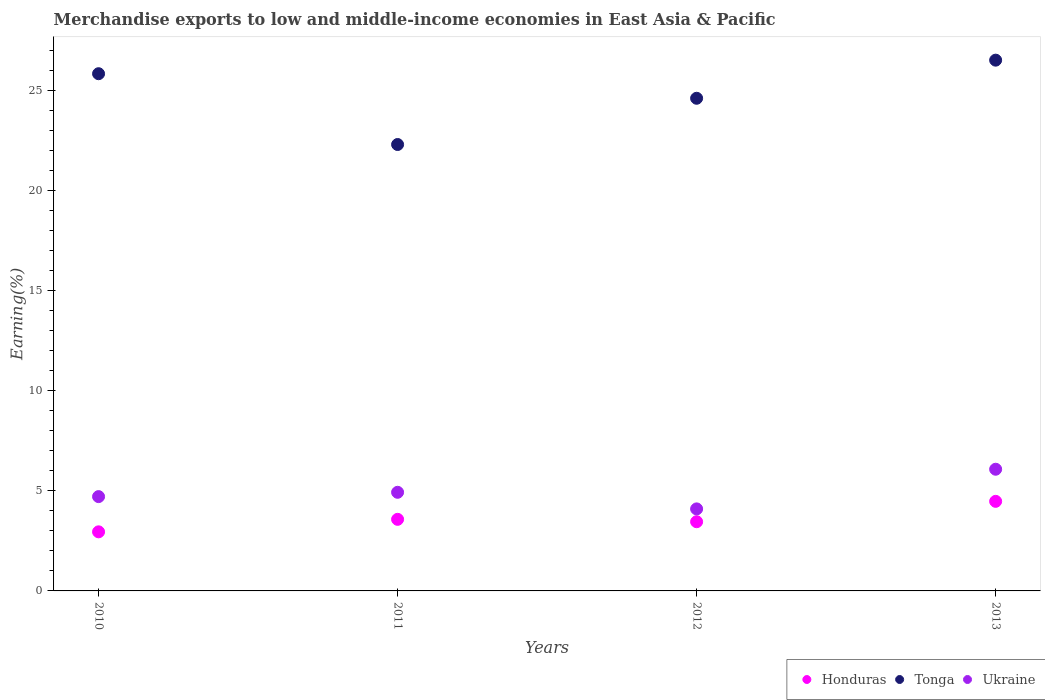What is the percentage of amount earned from merchandise exports in Ukraine in 2012?
Offer a terse response. 4.09. Across all years, what is the maximum percentage of amount earned from merchandise exports in Tonga?
Provide a succinct answer. 26.5. Across all years, what is the minimum percentage of amount earned from merchandise exports in Ukraine?
Make the answer very short. 4.09. In which year was the percentage of amount earned from merchandise exports in Tonga maximum?
Keep it short and to the point. 2013. What is the total percentage of amount earned from merchandise exports in Ukraine in the graph?
Provide a short and direct response. 19.8. What is the difference between the percentage of amount earned from merchandise exports in Ukraine in 2012 and that in 2013?
Your answer should be very brief. -1.98. What is the difference between the percentage of amount earned from merchandise exports in Ukraine in 2013 and the percentage of amount earned from merchandise exports in Honduras in 2010?
Provide a short and direct response. 3.12. What is the average percentage of amount earned from merchandise exports in Ukraine per year?
Keep it short and to the point. 4.95. In the year 2011, what is the difference between the percentage of amount earned from merchandise exports in Tonga and percentage of amount earned from merchandise exports in Honduras?
Your response must be concise. 18.71. What is the ratio of the percentage of amount earned from merchandise exports in Ukraine in 2012 to that in 2013?
Provide a short and direct response. 0.67. Is the percentage of amount earned from merchandise exports in Honduras in 2011 less than that in 2012?
Provide a short and direct response. No. What is the difference between the highest and the second highest percentage of amount earned from merchandise exports in Tonga?
Offer a terse response. 0.68. What is the difference between the highest and the lowest percentage of amount earned from merchandise exports in Honduras?
Give a very brief answer. 1.52. In how many years, is the percentage of amount earned from merchandise exports in Ukraine greater than the average percentage of amount earned from merchandise exports in Ukraine taken over all years?
Provide a short and direct response. 1. Is the sum of the percentage of amount earned from merchandise exports in Honduras in 2011 and 2012 greater than the maximum percentage of amount earned from merchandise exports in Tonga across all years?
Provide a short and direct response. No. Does the percentage of amount earned from merchandise exports in Tonga monotonically increase over the years?
Keep it short and to the point. No. Is the percentage of amount earned from merchandise exports in Ukraine strictly greater than the percentage of amount earned from merchandise exports in Honduras over the years?
Offer a very short reply. Yes. Is the percentage of amount earned from merchandise exports in Tonga strictly less than the percentage of amount earned from merchandise exports in Ukraine over the years?
Make the answer very short. No. How many dotlines are there?
Provide a succinct answer. 3. How many years are there in the graph?
Keep it short and to the point. 4. Are the values on the major ticks of Y-axis written in scientific E-notation?
Your response must be concise. No. Does the graph contain any zero values?
Provide a short and direct response. No. Does the graph contain grids?
Provide a succinct answer. No. How many legend labels are there?
Your answer should be very brief. 3. How are the legend labels stacked?
Provide a short and direct response. Horizontal. What is the title of the graph?
Your answer should be very brief. Merchandise exports to low and middle-income economies in East Asia & Pacific. What is the label or title of the Y-axis?
Make the answer very short. Earning(%). What is the Earning(%) in Honduras in 2010?
Offer a terse response. 2.95. What is the Earning(%) in Tonga in 2010?
Keep it short and to the point. 25.82. What is the Earning(%) of Ukraine in 2010?
Your answer should be compact. 4.71. What is the Earning(%) of Honduras in 2011?
Give a very brief answer. 3.57. What is the Earning(%) of Tonga in 2011?
Make the answer very short. 22.29. What is the Earning(%) in Ukraine in 2011?
Provide a succinct answer. 4.92. What is the Earning(%) in Honduras in 2012?
Keep it short and to the point. 3.45. What is the Earning(%) of Tonga in 2012?
Your response must be concise. 24.59. What is the Earning(%) in Ukraine in 2012?
Your answer should be very brief. 4.09. What is the Earning(%) in Honduras in 2013?
Your response must be concise. 4.47. What is the Earning(%) of Tonga in 2013?
Ensure brevity in your answer.  26.5. What is the Earning(%) of Ukraine in 2013?
Provide a short and direct response. 6.07. Across all years, what is the maximum Earning(%) in Honduras?
Offer a very short reply. 4.47. Across all years, what is the maximum Earning(%) of Tonga?
Make the answer very short. 26.5. Across all years, what is the maximum Earning(%) in Ukraine?
Your response must be concise. 6.07. Across all years, what is the minimum Earning(%) in Honduras?
Provide a short and direct response. 2.95. Across all years, what is the minimum Earning(%) in Tonga?
Ensure brevity in your answer.  22.29. Across all years, what is the minimum Earning(%) in Ukraine?
Offer a terse response. 4.09. What is the total Earning(%) in Honduras in the graph?
Keep it short and to the point. 14.45. What is the total Earning(%) of Tonga in the graph?
Keep it short and to the point. 99.19. What is the total Earning(%) in Ukraine in the graph?
Your answer should be compact. 19.8. What is the difference between the Earning(%) in Honduras in 2010 and that in 2011?
Your answer should be very brief. -0.62. What is the difference between the Earning(%) of Tonga in 2010 and that in 2011?
Your answer should be very brief. 3.53. What is the difference between the Earning(%) of Ukraine in 2010 and that in 2011?
Make the answer very short. -0.22. What is the difference between the Earning(%) in Honduras in 2010 and that in 2012?
Your answer should be very brief. -0.5. What is the difference between the Earning(%) of Tonga in 2010 and that in 2012?
Give a very brief answer. 1.23. What is the difference between the Earning(%) of Ukraine in 2010 and that in 2012?
Your answer should be compact. 0.61. What is the difference between the Earning(%) of Honduras in 2010 and that in 2013?
Provide a short and direct response. -1.52. What is the difference between the Earning(%) of Tonga in 2010 and that in 2013?
Offer a terse response. -0.68. What is the difference between the Earning(%) in Ukraine in 2010 and that in 2013?
Make the answer very short. -1.37. What is the difference between the Earning(%) of Honduras in 2011 and that in 2012?
Your answer should be compact. 0.12. What is the difference between the Earning(%) of Tonga in 2011 and that in 2012?
Make the answer very short. -2.31. What is the difference between the Earning(%) of Ukraine in 2011 and that in 2012?
Make the answer very short. 0.83. What is the difference between the Earning(%) in Honduras in 2011 and that in 2013?
Make the answer very short. -0.9. What is the difference between the Earning(%) in Tonga in 2011 and that in 2013?
Provide a short and direct response. -4.21. What is the difference between the Earning(%) in Ukraine in 2011 and that in 2013?
Give a very brief answer. -1.15. What is the difference between the Earning(%) in Honduras in 2012 and that in 2013?
Offer a very short reply. -1.02. What is the difference between the Earning(%) of Tonga in 2012 and that in 2013?
Make the answer very short. -1.9. What is the difference between the Earning(%) of Ukraine in 2012 and that in 2013?
Offer a very short reply. -1.98. What is the difference between the Earning(%) in Honduras in 2010 and the Earning(%) in Tonga in 2011?
Give a very brief answer. -19.34. What is the difference between the Earning(%) in Honduras in 2010 and the Earning(%) in Ukraine in 2011?
Your answer should be very brief. -1.97. What is the difference between the Earning(%) of Tonga in 2010 and the Earning(%) of Ukraine in 2011?
Offer a terse response. 20.9. What is the difference between the Earning(%) in Honduras in 2010 and the Earning(%) in Tonga in 2012?
Provide a short and direct response. -21.64. What is the difference between the Earning(%) of Honduras in 2010 and the Earning(%) of Ukraine in 2012?
Provide a succinct answer. -1.14. What is the difference between the Earning(%) in Tonga in 2010 and the Earning(%) in Ukraine in 2012?
Keep it short and to the point. 21.72. What is the difference between the Earning(%) of Honduras in 2010 and the Earning(%) of Tonga in 2013?
Provide a succinct answer. -23.55. What is the difference between the Earning(%) in Honduras in 2010 and the Earning(%) in Ukraine in 2013?
Ensure brevity in your answer.  -3.12. What is the difference between the Earning(%) of Tonga in 2010 and the Earning(%) of Ukraine in 2013?
Provide a succinct answer. 19.74. What is the difference between the Earning(%) in Honduras in 2011 and the Earning(%) in Tonga in 2012?
Keep it short and to the point. -21.02. What is the difference between the Earning(%) of Honduras in 2011 and the Earning(%) of Ukraine in 2012?
Ensure brevity in your answer.  -0.52. What is the difference between the Earning(%) in Tonga in 2011 and the Earning(%) in Ukraine in 2012?
Offer a very short reply. 18.19. What is the difference between the Earning(%) of Honduras in 2011 and the Earning(%) of Tonga in 2013?
Give a very brief answer. -22.92. What is the difference between the Earning(%) in Honduras in 2011 and the Earning(%) in Ukraine in 2013?
Make the answer very short. -2.5. What is the difference between the Earning(%) of Tonga in 2011 and the Earning(%) of Ukraine in 2013?
Your response must be concise. 16.21. What is the difference between the Earning(%) in Honduras in 2012 and the Earning(%) in Tonga in 2013?
Provide a short and direct response. -23.04. What is the difference between the Earning(%) in Honduras in 2012 and the Earning(%) in Ukraine in 2013?
Provide a succinct answer. -2.62. What is the difference between the Earning(%) of Tonga in 2012 and the Earning(%) of Ukraine in 2013?
Provide a short and direct response. 18.52. What is the average Earning(%) in Honduras per year?
Give a very brief answer. 3.61. What is the average Earning(%) of Tonga per year?
Offer a very short reply. 24.8. What is the average Earning(%) of Ukraine per year?
Offer a very short reply. 4.95. In the year 2010, what is the difference between the Earning(%) in Honduras and Earning(%) in Tonga?
Keep it short and to the point. -22.87. In the year 2010, what is the difference between the Earning(%) of Honduras and Earning(%) of Ukraine?
Your answer should be very brief. -1.76. In the year 2010, what is the difference between the Earning(%) in Tonga and Earning(%) in Ukraine?
Offer a very short reply. 21.11. In the year 2011, what is the difference between the Earning(%) of Honduras and Earning(%) of Tonga?
Provide a short and direct response. -18.71. In the year 2011, what is the difference between the Earning(%) in Honduras and Earning(%) in Ukraine?
Provide a succinct answer. -1.35. In the year 2011, what is the difference between the Earning(%) in Tonga and Earning(%) in Ukraine?
Provide a succinct answer. 17.36. In the year 2012, what is the difference between the Earning(%) of Honduras and Earning(%) of Tonga?
Give a very brief answer. -21.14. In the year 2012, what is the difference between the Earning(%) of Honduras and Earning(%) of Ukraine?
Your answer should be very brief. -0.64. In the year 2012, what is the difference between the Earning(%) in Tonga and Earning(%) in Ukraine?
Your answer should be compact. 20.5. In the year 2013, what is the difference between the Earning(%) in Honduras and Earning(%) in Tonga?
Offer a very short reply. -22.02. In the year 2013, what is the difference between the Earning(%) of Honduras and Earning(%) of Ukraine?
Keep it short and to the point. -1.6. In the year 2013, what is the difference between the Earning(%) in Tonga and Earning(%) in Ukraine?
Provide a succinct answer. 20.42. What is the ratio of the Earning(%) in Honduras in 2010 to that in 2011?
Your response must be concise. 0.83. What is the ratio of the Earning(%) in Tonga in 2010 to that in 2011?
Make the answer very short. 1.16. What is the ratio of the Earning(%) in Ukraine in 2010 to that in 2011?
Your answer should be very brief. 0.96. What is the ratio of the Earning(%) of Honduras in 2010 to that in 2012?
Your answer should be compact. 0.85. What is the ratio of the Earning(%) of Tonga in 2010 to that in 2012?
Provide a succinct answer. 1.05. What is the ratio of the Earning(%) of Ukraine in 2010 to that in 2012?
Provide a succinct answer. 1.15. What is the ratio of the Earning(%) of Honduras in 2010 to that in 2013?
Provide a succinct answer. 0.66. What is the ratio of the Earning(%) in Tonga in 2010 to that in 2013?
Your response must be concise. 0.97. What is the ratio of the Earning(%) of Ukraine in 2010 to that in 2013?
Keep it short and to the point. 0.78. What is the ratio of the Earning(%) in Honduras in 2011 to that in 2012?
Offer a very short reply. 1.03. What is the ratio of the Earning(%) of Tonga in 2011 to that in 2012?
Your response must be concise. 0.91. What is the ratio of the Earning(%) in Ukraine in 2011 to that in 2012?
Ensure brevity in your answer.  1.2. What is the ratio of the Earning(%) in Honduras in 2011 to that in 2013?
Your answer should be very brief. 0.8. What is the ratio of the Earning(%) of Tonga in 2011 to that in 2013?
Ensure brevity in your answer.  0.84. What is the ratio of the Earning(%) in Ukraine in 2011 to that in 2013?
Keep it short and to the point. 0.81. What is the ratio of the Earning(%) of Honduras in 2012 to that in 2013?
Offer a terse response. 0.77. What is the ratio of the Earning(%) of Tonga in 2012 to that in 2013?
Make the answer very short. 0.93. What is the ratio of the Earning(%) in Ukraine in 2012 to that in 2013?
Provide a short and direct response. 0.67. What is the difference between the highest and the second highest Earning(%) in Honduras?
Make the answer very short. 0.9. What is the difference between the highest and the second highest Earning(%) of Tonga?
Make the answer very short. 0.68. What is the difference between the highest and the second highest Earning(%) in Ukraine?
Provide a succinct answer. 1.15. What is the difference between the highest and the lowest Earning(%) in Honduras?
Ensure brevity in your answer.  1.52. What is the difference between the highest and the lowest Earning(%) of Tonga?
Provide a short and direct response. 4.21. What is the difference between the highest and the lowest Earning(%) of Ukraine?
Offer a terse response. 1.98. 